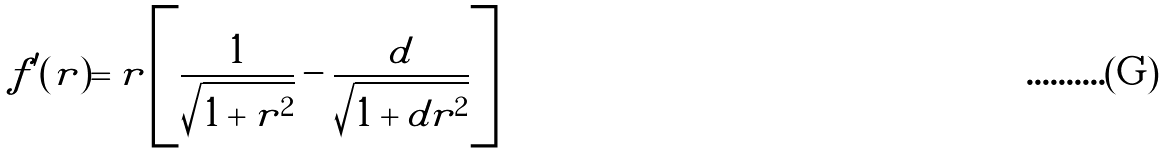Convert formula to latex. <formula><loc_0><loc_0><loc_500><loc_500>f ^ { \prime } ( r ) = r \left [ \frac { 1 } { \sqrt { 1 + r ^ { 2 } } } - \frac { d } { \sqrt { 1 + d r ^ { 2 } } } \right ]</formula> 